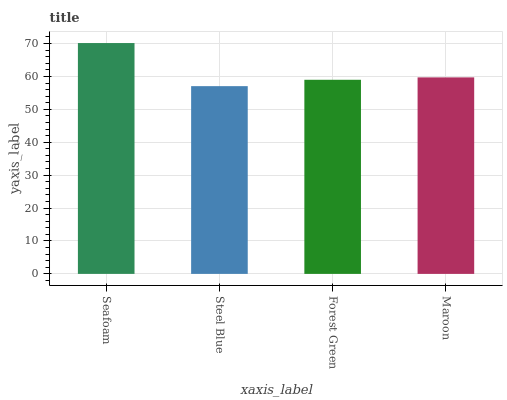Is Steel Blue the minimum?
Answer yes or no. Yes. Is Seafoam the maximum?
Answer yes or no. Yes. Is Forest Green the minimum?
Answer yes or no. No. Is Forest Green the maximum?
Answer yes or no. No. Is Forest Green greater than Steel Blue?
Answer yes or no. Yes. Is Steel Blue less than Forest Green?
Answer yes or no. Yes. Is Steel Blue greater than Forest Green?
Answer yes or no. No. Is Forest Green less than Steel Blue?
Answer yes or no. No. Is Maroon the high median?
Answer yes or no. Yes. Is Forest Green the low median?
Answer yes or no. Yes. Is Steel Blue the high median?
Answer yes or no. No. Is Seafoam the low median?
Answer yes or no. No. 